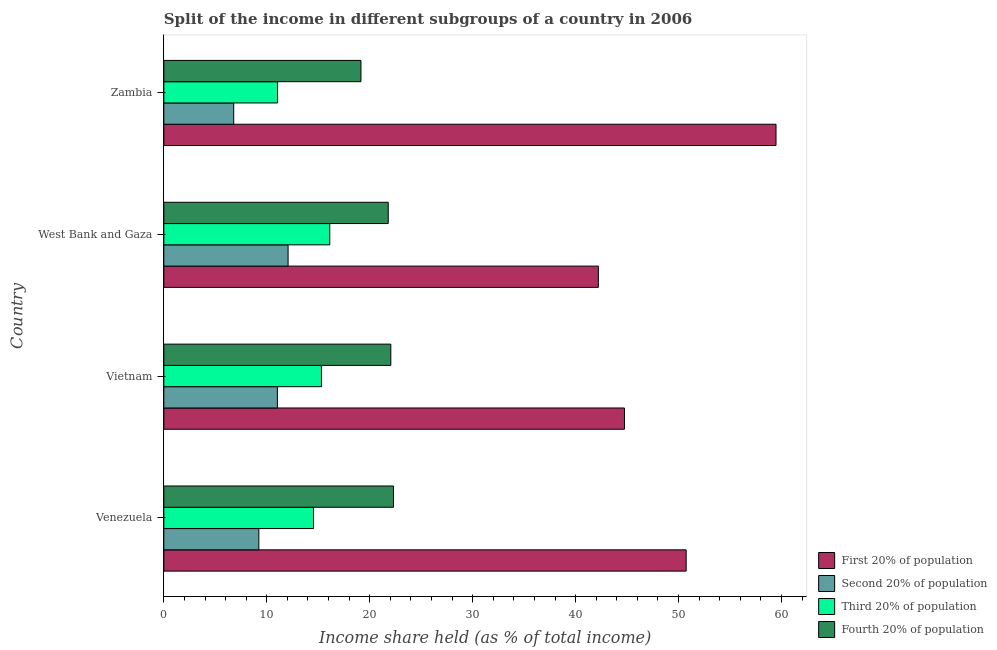Are the number of bars per tick equal to the number of legend labels?
Make the answer very short. Yes. What is the label of the 2nd group of bars from the top?
Your answer should be compact. West Bank and Gaza. In how many cases, is the number of bars for a given country not equal to the number of legend labels?
Offer a very short reply. 0. What is the share of the income held by fourth 20% of the population in Venezuela?
Provide a succinct answer. 22.31. Across all countries, what is the maximum share of the income held by fourth 20% of the population?
Offer a terse response. 22.31. Across all countries, what is the minimum share of the income held by first 20% of the population?
Your response must be concise. 42.21. In which country was the share of the income held by second 20% of the population maximum?
Ensure brevity in your answer.  West Bank and Gaza. In which country was the share of the income held by fourth 20% of the population minimum?
Make the answer very short. Zambia. What is the total share of the income held by first 20% of the population in the graph?
Make the answer very short. 197.17. What is the difference between the share of the income held by second 20% of the population in Venezuela and that in Zambia?
Provide a short and direct response. 2.44. What is the difference between the share of the income held by first 20% of the population in West Bank and Gaza and the share of the income held by third 20% of the population in Venezuela?
Offer a very short reply. 27.67. What is the average share of the income held by first 20% of the population per country?
Keep it short and to the point. 49.29. What is the difference between the share of the income held by second 20% of the population and share of the income held by first 20% of the population in Zambia?
Your response must be concise. -52.68. Is the difference between the share of the income held by third 20% of the population in Venezuela and West Bank and Gaza greater than the difference between the share of the income held by fourth 20% of the population in Venezuela and West Bank and Gaza?
Provide a succinct answer. No. What is the difference between the highest and the second highest share of the income held by third 20% of the population?
Ensure brevity in your answer.  0.81. What is the difference between the highest and the lowest share of the income held by first 20% of the population?
Make the answer very short. 17.26. In how many countries, is the share of the income held by third 20% of the population greater than the average share of the income held by third 20% of the population taken over all countries?
Your response must be concise. 3. Is the sum of the share of the income held by first 20% of the population in West Bank and Gaza and Zambia greater than the maximum share of the income held by third 20% of the population across all countries?
Keep it short and to the point. Yes. Is it the case that in every country, the sum of the share of the income held by second 20% of the population and share of the income held by first 20% of the population is greater than the sum of share of the income held by fourth 20% of the population and share of the income held by third 20% of the population?
Keep it short and to the point. Yes. What does the 2nd bar from the top in West Bank and Gaza represents?
Keep it short and to the point. Third 20% of population. What does the 2nd bar from the bottom in West Bank and Gaza represents?
Offer a terse response. Second 20% of population. Is it the case that in every country, the sum of the share of the income held by first 20% of the population and share of the income held by second 20% of the population is greater than the share of the income held by third 20% of the population?
Give a very brief answer. Yes. How many bars are there?
Provide a succinct answer. 16. Are all the bars in the graph horizontal?
Make the answer very short. Yes. What is the difference between two consecutive major ticks on the X-axis?
Your answer should be very brief. 10. Does the graph contain any zero values?
Provide a short and direct response. No. Does the graph contain grids?
Ensure brevity in your answer.  No. Where does the legend appear in the graph?
Offer a terse response. Bottom right. How many legend labels are there?
Provide a succinct answer. 4. How are the legend labels stacked?
Give a very brief answer. Vertical. What is the title of the graph?
Ensure brevity in your answer.  Split of the income in different subgroups of a country in 2006. What is the label or title of the X-axis?
Your response must be concise. Income share held (as % of total income). What is the label or title of the Y-axis?
Provide a succinct answer. Country. What is the Income share held (as % of total income) in First 20% of population in Venezuela?
Give a very brief answer. 50.74. What is the Income share held (as % of total income) in Second 20% of population in Venezuela?
Your response must be concise. 9.23. What is the Income share held (as % of total income) of Third 20% of population in Venezuela?
Make the answer very short. 14.54. What is the Income share held (as % of total income) of Fourth 20% of population in Venezuela?
Your answer should be very brief. 22.31. What is the Income share held (as % of total income) of First 20% of population in Vietnam?
Offer a very short reply. 44.75. What is the Income share held (as % of total income) of Second 20% of population in Vietnam?
Offer a very short reply. 11.03. What is the Income share held (as % of total income) of Third 20% of population in Vietnam?
Offer a very short reply. 15.31. What is the Income share held (as % of total income) of Fourth 20% of population in Vietnam?
Your answer should be very brief. 22.05. What is the Income share held (as % of total income) in First 20% of population in West Bank and Gaza?
Your answer should be very brief. 42.21. What is the Income share held (as % of total income) of Second 20% of population in West Bank and Gaza?
Keep it short and to the point. 12.07. What is the Income share held (as % of total income) in Third 20% of population in West Bank and Gaza?
Offer a terse response. 16.12. What is the Income share held (as % of total income) in Fourth 20% of population in West Bank and Gaza?
Offer a terse response. 21.8. What is the Income share held (as % of total income) in First 20% of population in Zambia?
Your answer should be compact. 59.47. What is the Income share held (as % of total income) of Second 20% of population in Zambia?
Your answer should be compact. 6.79. What is the Income share held (as % of total income) of Third 20% of population in Zambia?
Give a very brief answer. 11.05. What is the Income share held (as % of total income) in Fourth 20% of population in Zambia?
Give a very brief answer. 19.15. Across all countries, what is the maximum Income share held (as % of total income) in First 20% of population?
Give a very brief answer. 59.47. Across all countries, what is the maximum Income share held (as % of total income) in Second 20% of population?
Give a very brief answer. 12.07. Across all countries, what is the maximum Income share held (as % of total income) in Third 20% of population?
Provide a succinct answer. 16.12. Across all countries, what is the maximum Income share held (as % of total income) in Fourth 20% of population?
Ensure brevity in your answer.  22.31. Across all countries, what is the minimum Income share held (as % of total income) in First 20% of population?
Offer a terse response. 42.21. Across all countries, what is the minimum Income share held (as % of total income) of Second 20% of population?
Provide a short and direct response. 6.79. Across all countries, what is the minimum Income share held (as % of total income) in Third 20% of population?
Your response must be concise. 11.05. Across all countries, what is the minimum Income share held (as % of total income) in Fourth 20% of population?
Provide a short and direct response. 19.15. What is the total Income share held (as % of total income) of First 20% of population in the graph?
Ensure brevity in your answer.  197.17. What is the total Income share held (as % of total income) in Second 20% of population in the graph?
Offer a very short reply. 39.12. What is the total Income share held (as % of total income) in Third 20% of population in the graph?
Your answer should be very brief. 57.02. What is the total Income share held (as % of total income) in Fourth 20% of population in the graph?
Your response must be concise. 85.31. What is the difference between the Income share held (as % of total income) in First 20% of population in Venezuela and that in Vietnam?
Make the answer very short. 5.99. What is the difference between the Income share held (as % of total income) of Second 20% of population in Venezuela and that in Vietnam?
Your answer should be compact. -1.8. What is the difference between the Income share held (as % of total income) in Third 20% of population in Venezuela and that in Vietnam?
Your response must be concise. -0.77. What is the difference between the Income share held (as % of total income) of Fourth 20% of population in Venezuela and that in Vietnam?
Offer a terse response. 0.26. What is the difference between the Income share held (as % of total income) in First 20% of population in Venezuela and that in West Bank and Gaza?
Offer a terse response. 8.53. What is the difference between the Income share held (as % of total income) in Second 20% of population in Venezuela and that in West Bank and Gaza?
Keep it short and to the point. -2.84. What is the difference between the Income share held (as % of total income) in Third 20% of population in Venezuela and that in West Bank and Gaza?
Offer a terse response. -1.58. What is the difference between the Income share held (as % of total income) of Fourth 20% of population in Venezuela and that in West Bank and Gaza?
Ensure brevity in your answer.  0.51. What is the difference between the Income share held (as % of total income) in First 20% of population in Venezuela and that in Zambia?
Ensure brevity in your answer.  -8.73. What is the difference between the Income share held (as % of total income) of Second 20% of population in Venezuela and that in Zambia?
Provide a succinct answer. 2.44. What is the difference between the Income share held (as % of total income) in Third 20% of population in Venezuela and that in Zambia?
Make the answer very short. 3.49. What is the difference between the Income share held (as % of total income) of Fourth 20% of population in Venezuela and that in Zambia?
Keep it short and to the point. 3.16. What is the difference between the Income share held (as % of total income) of First 20% of population in Vietnam and that in West Bank and Gaza?
Offer a terse response. 2.54. What is the difference between the Income share held (as % of total income) in Second 20% of population in Vietnam and that in West Bank and Gaza?
Offer a very short reply. -1.04. What is the difference between the Income share held (as % of total income) in Third 20% of population in Vietnam and that in West Bank and Gaza?
Offer a terse response. -0.81. What is the difference between the Income share held (as % of total income) in First 20% of population in Vietnam and that in Zambia?
Give a very brief answer. -14.72. What is the difference between the Income share held (as % of total income) of Second 20% of population in Vietnam and that in Zambia?
Make the answer very short. 4.24. What is the difference between the Income share held (as % of total income) in Third 20% of population in Vietnam and that in Zambia?
Keep it short and to the point. 4.26. What is the difference between the Income share held (as % of total income) in Fourth 20% of population in Vietnam and that in Zambia?
Keep it short and to the point. 2.9. What is the difference between the Income share held (as % of total income) in First 20% of population in West Bank and Gaza and that in Zambia?
Offer a very short reply. -17.26. What is the difference between the Income share held (as % of total income) of Second 20% of population in West Bank and Gaza and that in Zambia?
Provide a succinct answer. 5.28. What is the difference between the Income share held (as % of total income) in Third 20% of population in West Bank and Gaza and that in Zambia?
Offer a terse response. 5.07. What is the difference between the Income share held (as % of total income) in Fourth 20% of population in West Bank and Gaza and that in Zambia?
Give a very brief answer. 2.65. What is the difference between the Income share held (as % of total income) in First 20% of population in Venezuela and the Income share held (as % of total income) in Second 20% of population in Vietnam?
Ensure brevity in your answer.  39.71. What is the difference between the Income share held (as % of total income) of First 20% of population in Venezuela and the Income share held (as % of total income) of Third 20% of population in Vietnam?
Ensure brevity in your answer.  35.43. What is the difference between the Income share held (as % of total income) of First 20% of population in Venezuela and the Income share held (as % of total income) of Fourth 20% of population in Vietnam?
Your response must be concise. 28.69. What is the difference between the Income share held (as % of total income) in Second 20% of population in Venezuela and the Income share held (as % of total income) in Third 20% of population in Vietnam?
Offer a very short reply. -6.08. What is the difference between the Income share held (as % of total income) of Second 20% of population in Venezuela and the Income share held (as % of total income) of Fourth 20% of population in Vietnam?
Give a very brief answer. -12.82. What is the difference between the Income share held (as % of total income) of Third 20% of population in Venezuela and the Income share held (as % of total income) of Fourth 20% of population in Vietnam?
Keep it short and to the point. -7.51. What is the difference between the Income share held (as % of total income) of First 20% of population in Venezuela and the Income share held (as % of total income) of Second 20% of population in West Bank and Gaza?
Provide a succinct answer. 38.67. What is the difference between the Income share held (as % of total income) in First 20% of population in Venezuela and the Income share held (as % of total income) in Third 20% of population in West Bank and Gaza?
Your answer should be very brief. 34.62. What is the difference between the Income share held (as % of total income) in First 20% of population in Venezuela and the Income share held (as % of total income) in Fourth 20% of population in West Bank and Gaza?
Your answer should be compact. 28.94. What is the difference between the Income share held (as % of total income) in Second 20% of population in Venezuela and the Income share held (as % of total income) in Third 20% of population in West Bank and Gaza?
Keep it short and to the point. -6.89. What is the difference between the Income share held (as % of total income) in Second 20% of population in Venezuela and the Income share held (as % of total income) in Fourth 20% of population in West Bank and Gaza?
Make the answer very short. -12.57. What is the difference between the Income share held (as % of total income) in Third 20% of population in Venezuela and the Income share held (as % of total income) in Fourth 20% of population in West Bank and Gaza?
Your answer should be very brief. -7.26. What is the difference between the Income share held (as % of total income) of First 20% of population in Venezuela and the Income share held (as % of total income) of Second 20% of population in Zambia?
Your answer should be very brief. 43.95. What is the difference between the Income share held (as % of total income) in First 20% of population in Venezuela and the Income share held (as % of total income) in Third 20% of population in Zambia?
Provide a succinct answer. 39.69. What is the difference between the Income share held (as % of total income) in First 20% of population in Venezuela and the Income share held (as % of total income) in Fourth 20% of population in Zambia?
Provide a succinct answer. 31.59. What is the difference between the Income share held (as % of total income) of Second 20% of population in Venezuela and the Income share held (as % of total income) of Third 20% of population in Zambia?
Offer a terse response. -1.82. What is the difference between the Income share held (as % of total income) in Second 20% of population in Venezuela and the Income share held (as % of total income) in Fourth 20% of population in Zambia?
Keep it short and to the point. -9.92. What is the difference between the Income share held (as % of total income) in Third 20% of population in Venezuela and the Income share held (as % of total income) in Fourth 20% of population in Zambia?
Keep it short and to the point. -4.61. What is the difference between the Income share held (as % of total income) in First 20% of population in Vietnam and the Income share held (as % of total income) in Second 20% of population in West Bank and Gaza?
Offer a terse response. 32.68. What is the difference between the Income share held (as % of total income) of First 20% of population in Vietnam and the Income share held (as % of total income) of Third 20% of population in West Bank and Gaza?
Your response must be concise. 28.63. What is the difference between the Income share held (as % of total income) in First 20% of population in Vietnam and the Income share held (as % of total income) in Fourth 20% of population in West Bank and Gaza?
Your response must be concise. 22.95. What is the difference between the Income share held (as % of total income) of Second 20% of population in Vietnam and the Income share held (as % of total income) of Third 20% of population in West Bank and Gaza?
Make the answer very short. -5.09. What is the difference between the Income share held (as % of total income) of Second 20% of population in Vietnam and the Income share held (as % of total income) of Fourth 20% of population in West Bank and Gaza?
Provide a short and direct response. -10.77. What is the difference between the Income share held (as % of total income) of Third 20% of population in Vietnam and the Income share held (as % of total income) of Fourth 20% of population in West Bank and Gaza?
Your answer should be compact. -6.49. What is the difference between the Income share held (as % of total income) in First 20% of population in Vietnam and the Income share held (as % of total income) in Second 20% of population in Zambia?
Give a very brief answer. 37.96. What is the difference between the Income share held (as % of total income) of First 20% of population in Vietnam and the Income share held (as % of total income) of Third 20% of population in Zambia?
Make the answer very short. 33.7. What is the difference between the Income share held (as % of total income) in First 20% of population in Vietnam and the Income share held (as % of total income) in Fourth 20% of population in Zambia?
Give a very brief answer. 25.6. What is the difference between the Income share held (as % of total income) of Second 20% of population in Vietnam and the Income share held (as % of total income) of Third 20% of population in Zambia?
Ensure brevity in your answer.  -0.02. What is the difference between the Income share held (as % of total income) in Second 20% of population in Vietnam and the Income share held (as % of total income) in Fourth 20% of population in Zambia?
Your answer should be compact. -8.12. What is the difference between the Income share held (as % of total income) of Third 20% of population in Vietnam and the Income share held (as % of total income) of Fourth 20% of population in Zambia?
Ensure brevity in your answer.  -3.84. What is the difference between the Income share held (as % of total income) of First 20% of population in West Bank and Gaza and the Income share held (as % of total income) of Second 20% of population in Zambia?
Your answer should be compact. 35.42. What is the difference between the Income share held (as % of total income) in First 20% of population in West Bank and Gaza and the Income share held (as % of total income) in Third 20% of population in Zambia?
Provide a succinct answer. 31.16. What is the difference between the Income share held (as % of total income) in First 20% of population in West Bank and Gaza and the Income share held (as % of total income) in Fourth 20% of population in Zambia?
Keep it short and to the point. 23.06. What is the difference between the Income share held (as % of total income) in Second 20% of population in West Bank and Gaza and the Income share held (as % of total income) in Fourth 20% of population in Zambia?
Offer a terse response. -7.08. What is the difference between the Income share held (as % of total income) in Third 20% of population in West Bank and Gaza and the Income share held (as % of total income) in Fourth 20% of population in Zambia?
Provide a short and direct response. -3.03. What is the average Income share held (as % of total income) of First 20% of population per country?
Your answer should be compact. 49.29. What is the average Income share held (as % of total income) of Second 20% of population per country?
Give a very brief answer. 9.78. What is the average Income share held (as % of total income) in Third 20% of population per country?
Give a very brief answer. 14.26. What is the average Income share held (as % of total income) in Fourth 20% of population per country?
Give a very brief answer. 21.33. What is the difference between the Income share held (as % of total income) in First 20% of population and Income share held (as % of total income) in Second 20% of population in Venezuela?
Provide a short and direct response. 41.51. What is the difference between the Income share held (as % of total income) of First 20% of population and Income share held (as % of total income) of Third 20% of population in Venezuela?
Make the answer very short. 36.2. What is the difference between the Income share held (as % of total income) of First 20% of population and Income share held (as % of total income) of Fourth 20% of population in Venezuela?
Provide a short and direct response. 28.43. What is the difference between the Income share held (as % of total income) of Second 20% of population and Income share held (as % of total income) of Third 20% of population in Venezuela?
Ensure brevity in your answer.  -5.31. What is the difference between the Income share held (as % of total income) of Second 20% of population and Income share held (as % of total income) of Fourth 20% of population in Venezuela?
Make the answer very short. -13.08. What is the difference between the Income share held (as % of total income) of Third 20% of population and Income share held (as % of total income) of Fourth 20% of population in Venezuela?
Your response must be concise. -7.77. What is the difference between the Income share held (as % of total income) of First 20% of population and Income share held (as % of total income) of Second 20% of population in Vietnam?
Offer a very short reply. 33.72. What is the difference between the Income share held (as % of total income) in First 20% of population and Income share held (as % of total income) in Third 20% of population in Vietnam?
Keep it short and to the point. 29.44. What is the difference between the Income share held (as % of total income) in First 20% of population and Income share held (as % of total income) in Fourth 20% of population in Vietnam?
Provide a short and direct response. 22.7. What is the difference between the Income share held (as % of total income) in Second 20% of population and Income share held (as % of total income) in Third 20% of population in Vietnam?
Provide a short and direct response. -4.28. What is the difference between the Income share held (as % of total income) in Second 20% of population and Income share held (as % of total income) in Fourth 20% of population in Vietnam?
Offer a very short reply. -11.02. What is the difference between the Income share held (as % of total income) of Third 20% of population and Income share held (as % of total income) of Fourth 20% of population in Vietnam?
Provide a succinct answer. -6.74. What is the difference between the Income share held (as % of total income) of First 20% of population and Income share held (as % of total income) of Second 20% of population in West Bank and Gaza?
Keep it short and to the point. 30.14. What is the difference between the Income share held (as % of total income) of First 20% of population and Income share held (as % of total income) of Third 20% of population in West Bank and Gaza?
Your response must be concise. 26.09. What is the difference between the Income share held (as % of total income) of First 20% of population and Income share held (as % of total income) of Fourth 20% of population in West Bank and Gaza?
Provide a short and direct response. 20.41. What is the difference between the Income share held (as % of total income) in Second 20% of population and Income share held (as % of total income) in Third 20% of population in West Bank and Gaza?
Ensure brevity in your answer.  -4.05. What is the difference between the Income share held (as % of total income) in Second 20% of population and Income share held (as % of total income) in Fourth 20% of population in West Bank and Gaza?
Provide a succinct answer. -9.73. What is the difference between the Income share held (as % of total income) in Third 20% of population and Income share held (as % of total income) in Fourth 20% of population in West Bank and Gaza?
Your response must be concise. -5.68. What is the difference between the Income share held (as % of total income) in First 20% of population and Income share held (as % of total income) in Second 20% of population in Zambia?
Offer a terse response. 52.68. What is the difference between the Income share held (as % of total income) of First 20% of population and Income share held (as % of total income) of Third 20% of population in Zambia?
Offer a terse response. 48.42. What is the difference between the Income share held (as % of total income) of First 20% of population and Income share held (as % of total income) of Fourth 20% of population in Zambia?
Your response must be concise. 40.32. What is the difference between the Income share held (as % of total income) of Second 20% of population and Income share held (as % of total income) of Third 20% of population in Zambia?
Provide a short and direct response. -4.26. What is the difference between the Income share held (as % of total income) of Second 20% of population and Income share held (as % of total income) of Fourth 20% of population in Zambia?
Your answer should be very brief. -12.36. What is the difference between the Income share held (as % of total income) in Third 20% of population and Income share held (as % of total income) in Fourth 20% of population in Zambia?
Provide a short and direct response. -8.1. What is the ratio of the Income share held (as % of total income) of First 20% of population in Venezuela to that in Vietnam?
Offer a terse response. 1.13. What is the ratio of the Income share held (as % of total income) in Second 20% of population in Venezuela to that in Vietnam?
Your answer should be very brief. 0.84. What is the ratio of the Income share held (as % of total income) in Third 20% of population in Venezuela to that in Vietnam?
Keep it short and to the point. 0.95. What is the ratio of the Income share held (as % of total income) in Fourth 20% of population in Venezuela to that in Vietnam?
Your response must be concise. 1.01. What is the ratio of the Income share held (as % of total income) in First 20% of population in Venezuela to that in West Bank and Gaza?
Keep it short and to the point. 1.2. What is the ratio of the Income share held (as % of total income) of Second 20% of population in Venezuela to that in West Bank and Gaza?
Your answer should be very brief. 0.76. What is the ratio of the Income share held (as % of total income) in Third 20% of population in Venezuela to that in West Bank and Gaza?
Offer a very short reply. 0.9. What is the ratio of the Income share held (as % of total income) in Fourth 20% of population in Venezuela to that in West Bank and Gaza?
Make the answer very short. 1.02. What is the ratio of the Income share held (as % of total income) of First 20% of population in Venezuela to that in Zambia?
Your response must be concise. 0.85. What is the ratio of the Income share held (as % of total income) in Second 20% of population in Venezuela to that in Zambia?
Keep it short and to the point. 1.36. What is the ratio of the Income share held (as % of total income) of Third 20% of population in Venezuela to that in Zambia?
Your answer should be very brief. 1.32. What is the ratio of the Income share held (as % of total income) of Fourth 20% of population in Venezuela to that in Zambia?
Your response must be concise. 1.17. What is the ratio of the Income share held (as % of total income) in First 20% of population in Vietnam to that in West Bank and Gaza?
Provide a short and direct response. 1.06. What is the ratio of the Income share held (as % of total income) of Second 20% of population in Vietnam to that in West Bank and Gaza?
Offer a terse response. 0.91. What is the ratio of the Income share held (as % of total income) of Third 20% of population in Vietnam to that in West Bank and Gaza?
Offer a very short reply. 0.95. What is the ratio of the Income share held (as % of total income) of Fourth 20% of population in Vietnam to that in West Bank and Gaza?
Give a very brief answer. 1.01. What is the ratio of the Income share held (as % of total income) in First 20% of population in Vietnam to that in Zambia?
Give a very brief answer. 0.75. What is the ratio of the Income share held (as % of total income) in Second 20% of population in Vietnam to that in Zambia?
Make the answer very short. 1.62. What is the ratio of the Income share held (as % of total income) of Third 20% of population in Vietnam to that in Zambia?
Ensure brevity in your answer.  1.39. What is the ratio of the Income share held (as % of total income) in Fourth 20% of population in Vietnam to that in Zambia?
Keep it short and to the point. 1.15. What is the ratio of the Income share held (as % of total income) in First 20% of population in West Bank and Gaza to that in Zambia?
Ensure brevity in your answer.  0.71. What is the ratio of the Income share held (as % of total income) in Second 20% of population in West Bank and Gaza to that in Zambia?
Your answer should be very brief. 1.78. What is the ratio of the Income share held (as % of total income) of Third 20% of population in West Bank and Gaza to that in Zambia?
Keep it short and to the point. 1.46. What is the ratio of the Income share held (as % of total income) in Fourth 20% of population in West Bank and Gaza to that in Zambia?
Provide a succinct answer. 1.14. What is the difference between the highest and the second highest Income share held (as % of total income) in First 20% of population?
Provide a short and direct response. 8.73. What is the difference between the highest and the second highest Income share held (as % of total income) in Third 20% of population?
Your answer should be compact. 0.81. What is the difference between the highest and the second highest Income share held (as % of total income) of Fourth 20% of population?
Make the answer very short. 0.26. What is the difference between the highest and the lowest Income share held (as % of total income) of First 20% of population?
Your answer should be very brief. 17.26. What is the difference between the highest and the lowest Income share held (as % of total income) of Second 20% of population?
Give a very brief answer. 5.28. What is the difference between the highest and the lowest Income share held (as % of total income) of Third 20% of population?
Offer a very short reply. 5.07. What is the difference between the highest and the lowest Income share held (as % of total income) of Fourth 20% of population?
Your response must be concise. 3.16. 